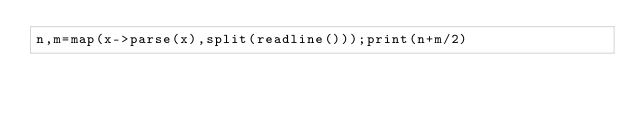<code> <loc_0><loc_0><loc_500><loc_500><_Julia_>n,m=map(x->parse(x),split(readline()));print(n+m/2)</code> 